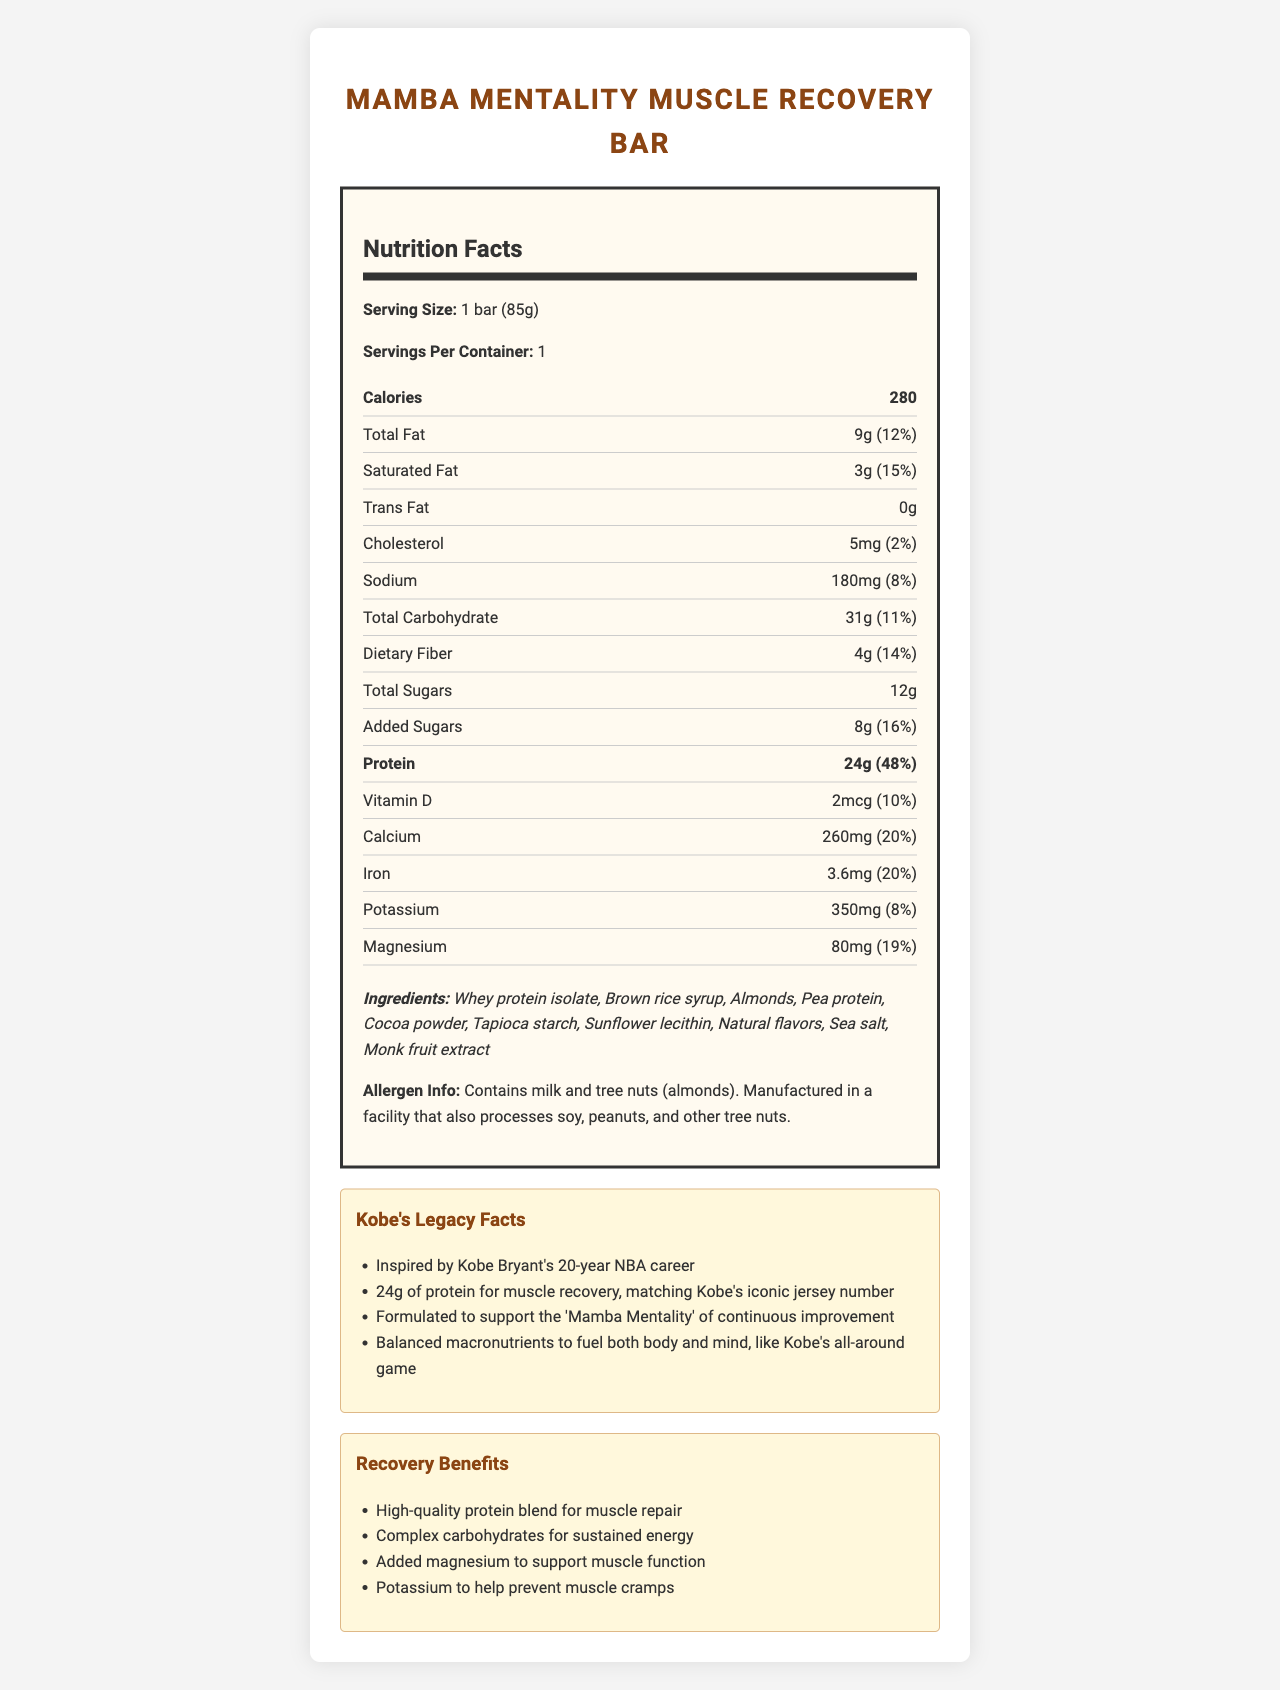how many calories are in one serving of the Mamba Mentality Muscle Recovery Bar? The document states that the nutrition facts for one serving (which is one bar) include 280 calories.
Answer: 280 what is the amount of protein in the Mamba Mentality Muscle Recovery Bar? The nutrition label specifies that there are 24g of protein per serving.
Answer: 24g what allergens are included in the Mamba Mentality Muscle Recovery Bar? The allergen information indicates that the bar contains milk and tree nuts (almonds).
Answer: Milk and tree nuts (almonds) what percentage of the daily value of dietary fiber does this bar provide? The document lists the dietary fiber amount as 4g, which is 14% of the daily value.
Answer: 14% what are the main ingredients in the Mamba Mentality Muscle Recovery Bar? The ingredients list includes these main components.
Answer: Whey protein isolate, Brown rice syrup, Almonds, Pea protein, and Cocoa powder what is the serving size for the Mamba Mentality Muscle Recovery Bar? The serving size is specified as 1 bar, which weighs 85g.
Answer: 1 bar (85g) which legacy of Kobe Bryant is highlighted by the protein content of the bar? A. His scoring average B. His jersey number C. His number of championship titles D. His years in the NBA The bar has 24g of protein, which matches Kobe's iconic jersey number 24.
Answer: B what recovery benefits does the bar provide? A. Muscle repair B. Improved digestion C. Reduced stress The document highlights muscle repair as a recovery benefit.
Answer: A is there any trans fat in the Mamba Mentality Muscle Recovery Bar? The document states that the amount of trans fat is 0g.
Answer: No summarize the main idea of the Mamba Mentality Muscle Recovery Bar document. The summary captures the product's inspiration, nutritional benefits, components, and supporting information highlighting Kobe Bryant's legacy and recovery benefits.
Answer: The Mamba Mentality Muscle Recovery Bar is a protein bar inspired by Kobe Bryant's legacy, formulated to aid muscle recovery and continuous improvement. It provides 24g of protein, essential macronutrients, and several minerals to support muscle function and prevent cramps. It also contains various ingredients and has allergens such as milk and tree nuts. how much sodium does the Mamba Mentality Muscle Recovery Bar contain? The nutrition label states that the bar contains 180mg of sodium.
Answer: 180mg why was the number 24 chosen for the amount of protein in this bar? The document explicitly mentions that the 24g of protein is in alignment with Kobe Bryant's iconic jersey number 24.
Answer: It matches Kobe's iconic jersey number. how would you describe the macronutrient balance in the Mamba Mentality Muscle Recovery Bar? This analysis is based on the nutritional breakdown provided, emphasizing Kobe Bryant's all-around game.
Answer: The bar provides a balanced mix of protein (24g), total fat (9g), and total carbohydrates (31g), designed to fuel both the body and mind. how much sugar is added to the Mamba Mentality Muscle Recovery Bar? A. 4g B. 8g C. 12g The document states that the added sugars amount to 8g.
Answer: B what is the main goal of the 'Mamba Mentality' as presented in this document? The Kobe Legacy Facts section mentions that the bar is formulated to support the 'Mamba Mentality,' which is about continuous improvement.
Answer: Continuous improvement can this bar be considered vegan? The document mentions milk as an allergen but doesn't specify whether or not the bar includes any other non-vegan ingredients apart from whey protein isolate.
Answer: Not enough information what mineral in the Mamba Mentality Muscle Recovery Bar helps prevent muscle cramps? The document lists potassium as helping to prevent muscle cramps and provides its amount as 350mg.
Answer: Potassium 